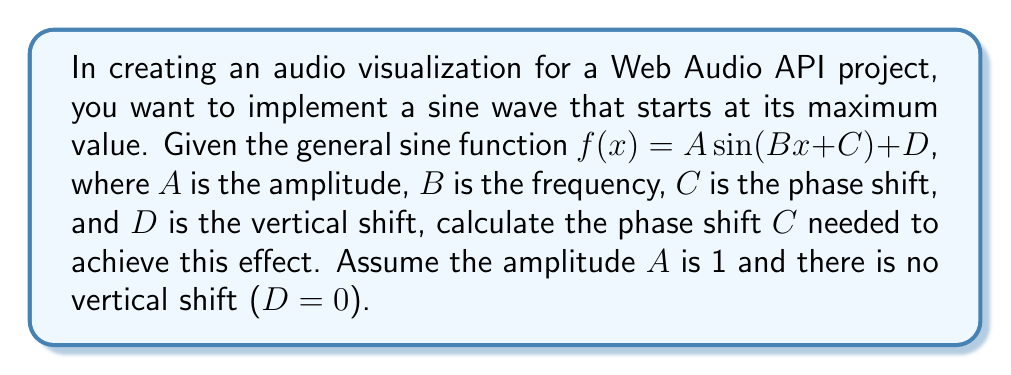Can you answer this question? To solve this problem, let's follow these steps:

1) The standard sine function $\sin(x)$ starts at 0 when $x = 0$. We want our function to start at its maximum value, which for sine is 1.

2) We know that $\sin(x)$ reaches its maximum value of 1 when $x = \frac{\pi}{2}$ radians (or 90°).

3) To shift the sine function so that it starts at its maximum, we need to shift it to the left by $\frac{\pi}{2}$.

4) In the general sine function $f(x) = A \sin(Bx + C) + D$, the phase shift is represented by $C$.

5) To shift the function to the left, we add a positive value inside the parentheses. Therefore, we need to add $\frac{\pi}{2}$ to the argument of the sine function.

6) This means our phase shift $C$ should be equal to $\frac{\pi}{2}$.

7) Our final function will be $f(x) = \sin(x + \frac{\pi}{2})$, which is equivalent to $f(x) = \cos(x)$.

This solution is particularly relevant for audio visualizations in Web Audio API, as it allows you to start your waveform at its peak, which can create interesting visual effects when combined with audio data.
Answer: The required phase shift is $C = \frac{\pi}{2}$ radians. 